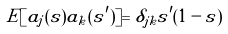Convert formula to latex. <formula><loc_0><loc_0><loc_500><loc_500>E [ a _ { j } ( s ) a _ { k } ( s ^ { \prime } ) ] = \delta _ { j k } s ^ { \prime } ( 1 - s )</formula> 